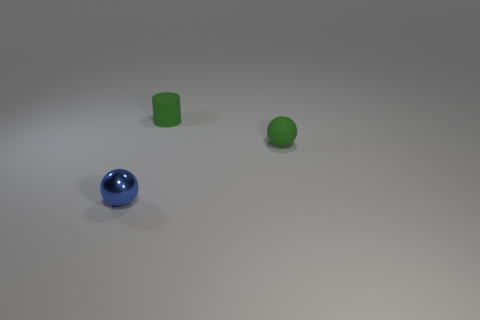Add 2 metal balls. How many objects exist? 5 Subtract all cylinders. How many objects are left? 2 Subtract 1 blue spheres. How many objects are left? 2 Subtract all green matte cylinders. Subtract all cylinders. How many objects are left? 1 Add 1 green matte cylinders. How many green matte cylinders are left? 2 Add 2 big rubber cubes. How many big rubber cubes exist? 2 